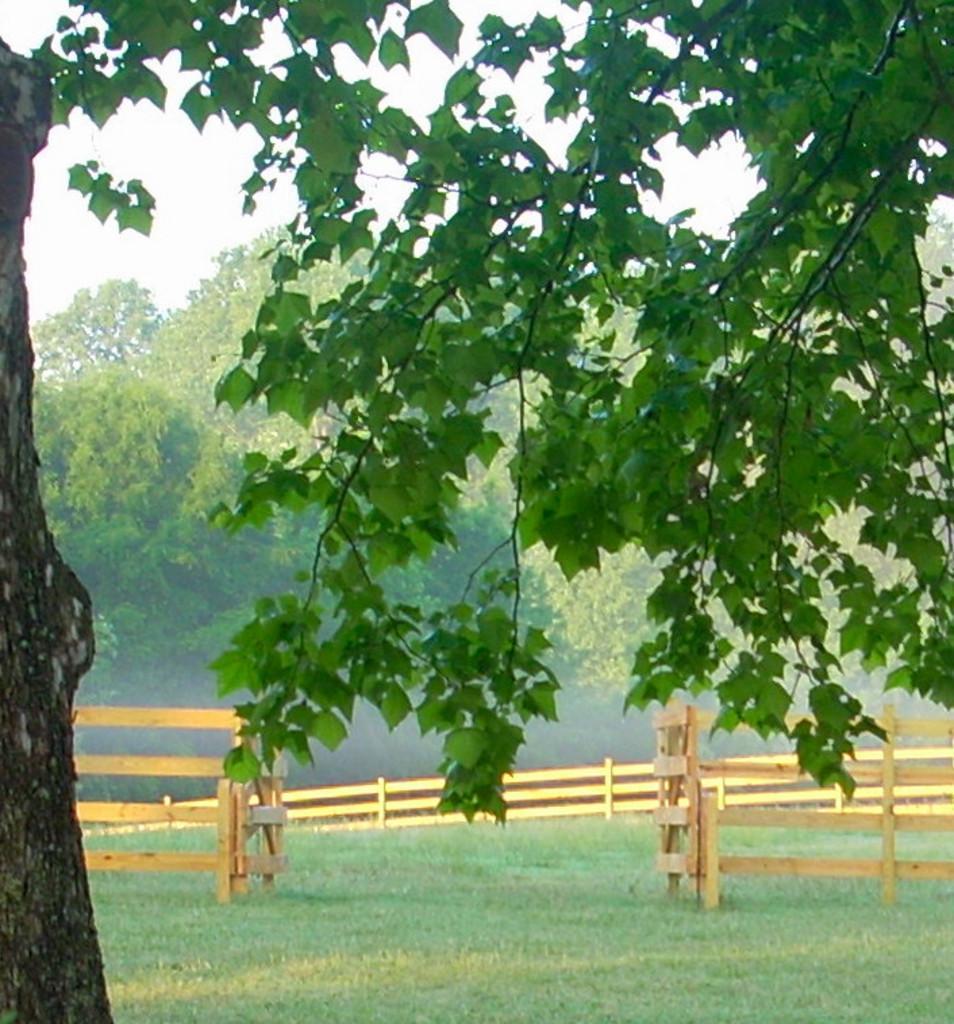How would you summarize this image in a sentence or two? In this image in the front there is a tree. In the center there is grass on the ground and there is a wooden fence. In the background there are trees and the sky is cloudy. 